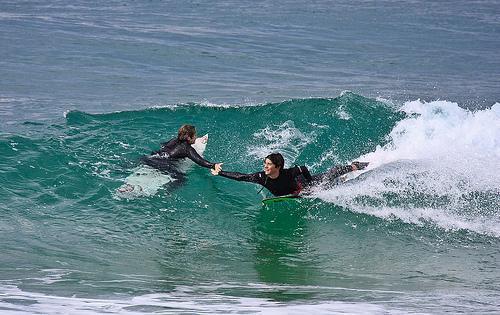How many hands are visible?
Give a very brief answer. 2. How many men are wearing glasses?
Give a very brief answer. 1. How many feet are visible?
Give a very brief answer. 1. How many people are in the water?
Give a very brief answer. 2. How many waves are visible?
Give a very brief answer. 1. How many surfers are in the ocean?
Give a very brief answer. 2. 